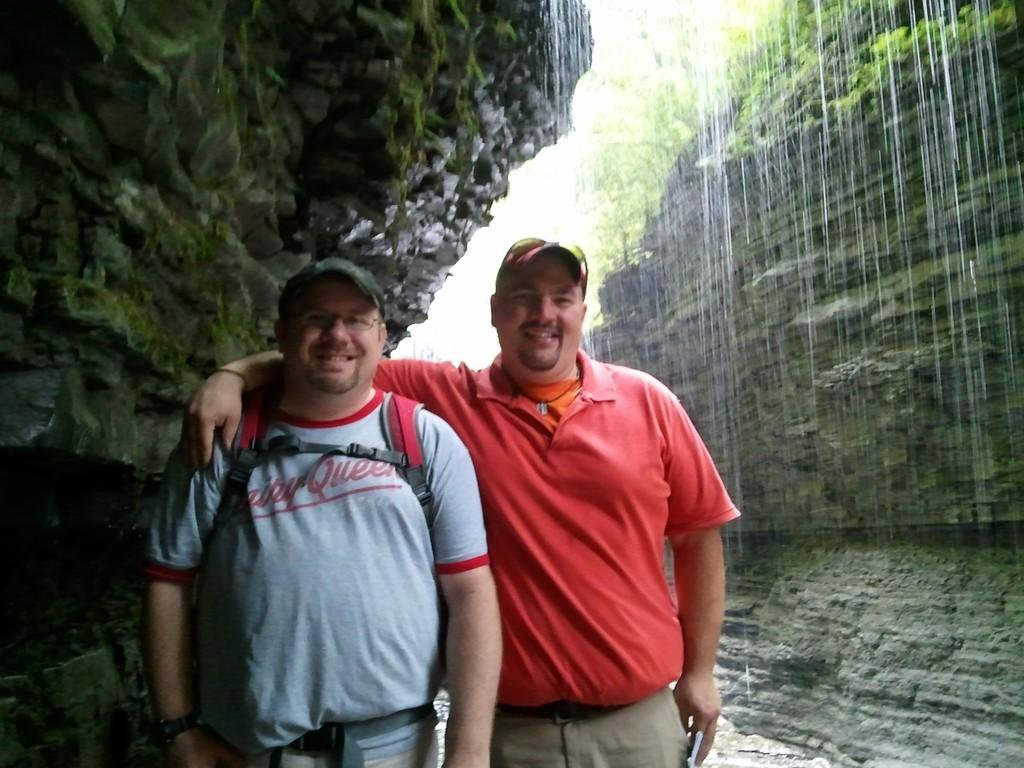<image>
Summarize the visual content of the image. Two men pose for a picture under a waterfall, while the man on the left wears a shirt saying Dairy Queen. 